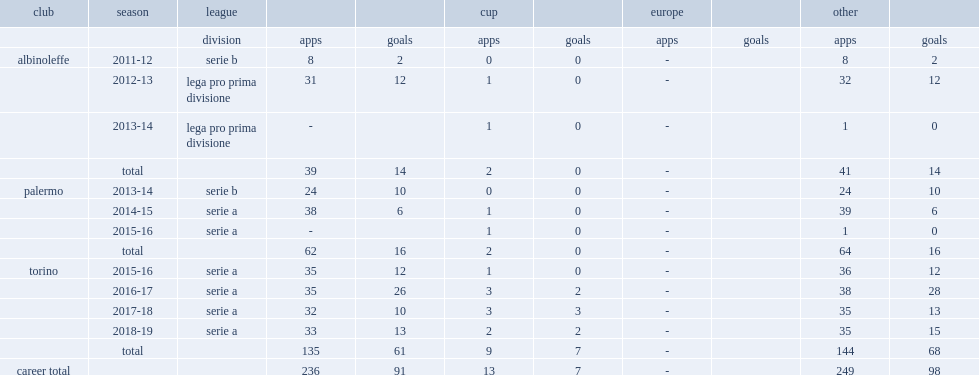Which league did andrea belotti sign by palermo played in the 2013-14 season and by torino in 2015? Serie b. 